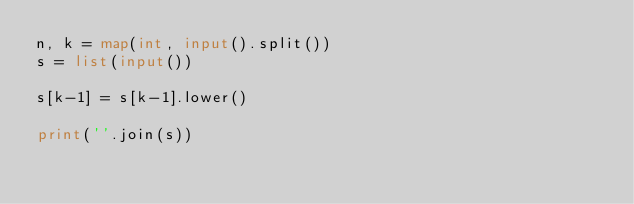Convert code to text. <code><loc_0><loc_0><loc_500><loc_500><_Python_>n, k = map(int, input().split())
s = list(input())

s[k-1] = s[k-1].lower()

print(''.join(s))</code> 